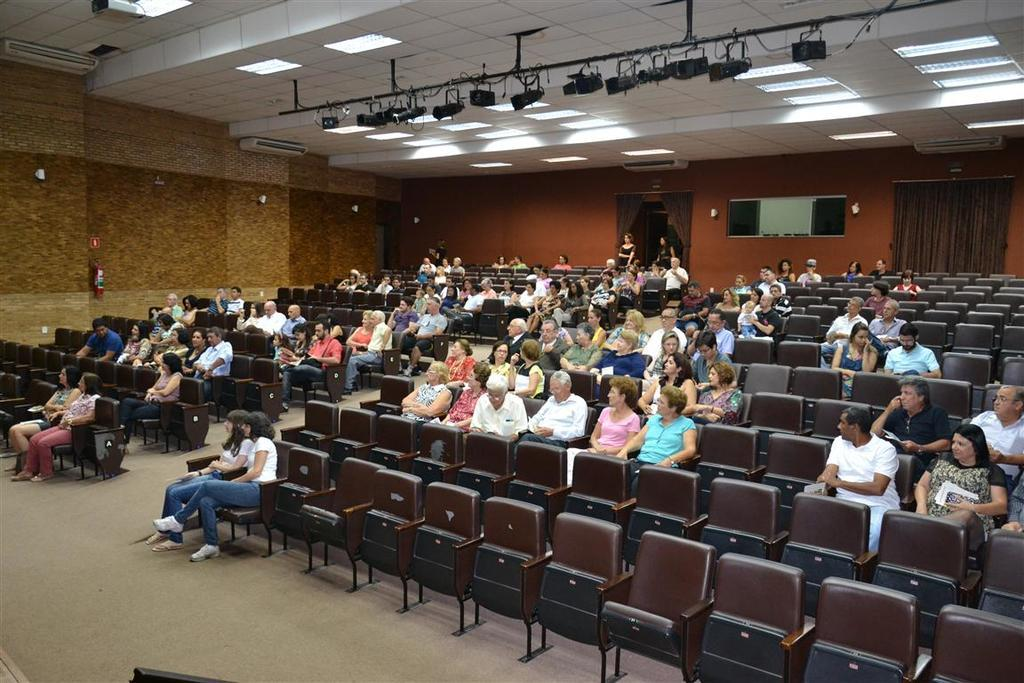What type of space is depicted in the image? There is a hall in the image. What are the people in the hall doing? There are people sitting on chairs in the hall. What can be seen on the roof of the hall? There are lights on the roof of the hall. What type of rod is being used by the minister in the image? There is no minister or rod present in the image. On which side of the hall are the people sitting? The provided facts do not specify the side of the hall where the people are sitting. 